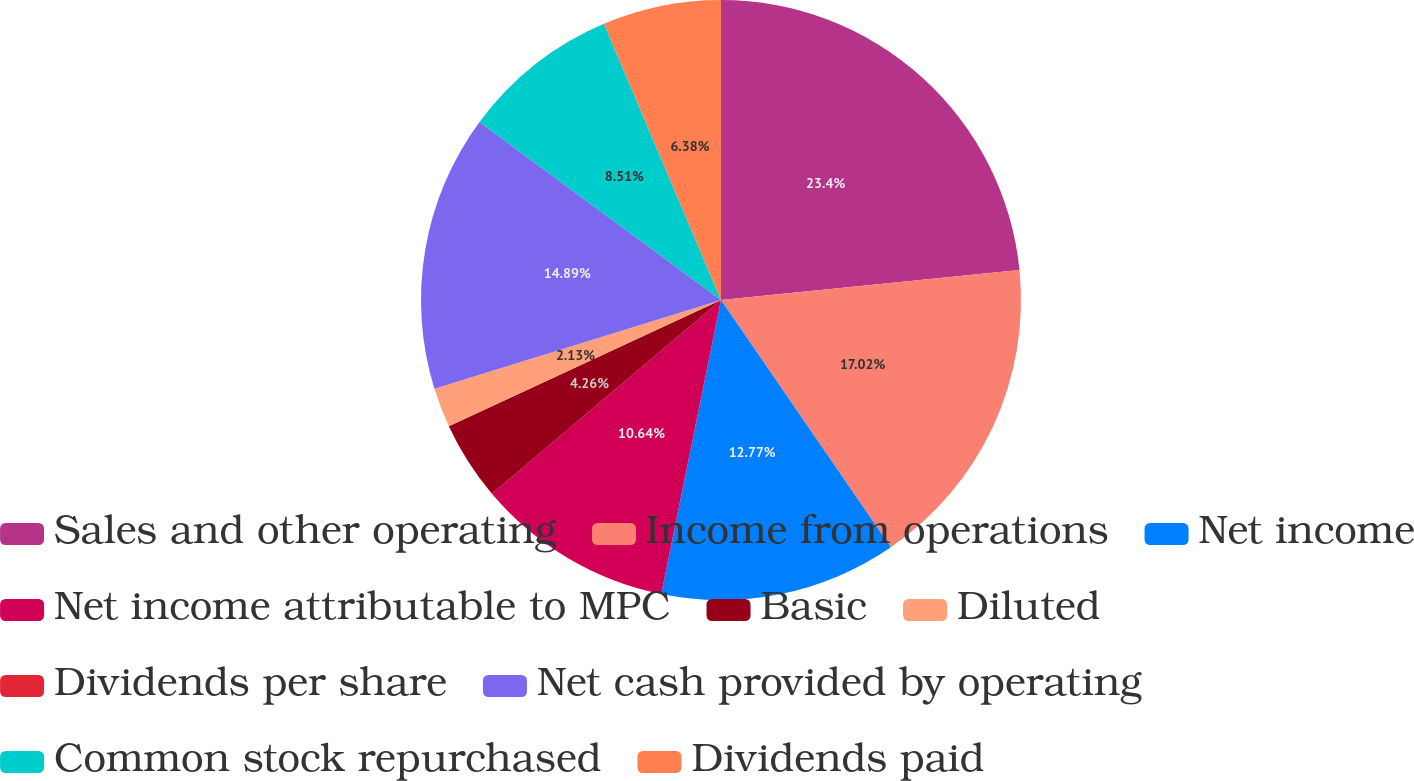<chart> <loc_0><loc_0><loc_500><loc_500><pie_chart><fcel>Sales and other operating<fcel>Income from operations<fcel>Net income<fcel>Net income attributable to MPC<fcel>Basic<fcel>Diluted<fcel>Dividends per share<fcel>Net cash provided by operating<fcel>Common stock repurchased<fcel>Dividends paid<nl><fcel>23.4%<fcel>17.02%<fcel>12.77%<fcel>10.64%<fcel>4.26%<fcel>2.13%<fcel>0.0%<fcel>14.89%<fcel>8.51%<fcel>6.38%<nl></chart> 